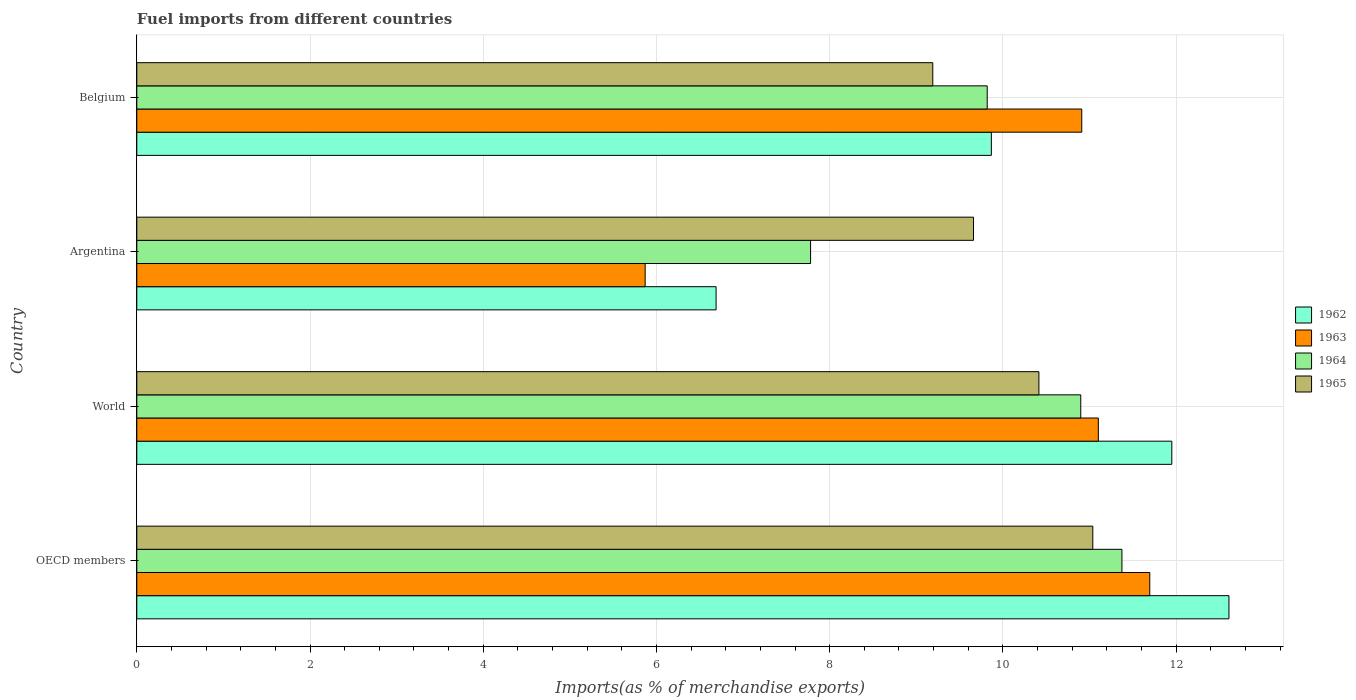How many bars are there on the 1st tick from the top?
Keep it short and to the point. 4. How many bars are there on the 4th tick from the bottom?
Provide a short and direct response. 4. What is the label of the 1st group of bars from the top?
Ensure brevity in your answer.  Belgium. In how many cases, is the number of bars for a given country not equal to the number of legend labels?
Keep it short and to the point. 0. What is the percentage of imports to different countries in 1964 in Argentina?
Offer a terse response. 7.78. Across all countries, what is the maximum percentage of imports to different countries in 1963?
Provide a short and direct response. 11.7. Across all countries, what is the minimum percentage of imports to different countries in 1962?
Offer a very short reply. 6.69. In which country was the percentage of imports to different countries in 1962 minimum?
Your response must be concise. Argentina. What is the total percentage of imports to different countries in 1964 in the graph?
Ensure brevity in your answer.  39.87. What is the difference between the percentage of imports to different countries in 1964 in OECD members and that in World?
Offer a terse response. 0.48. What is the difference between the percentage of imports to different countries in 1965 in Argentina and the percentage of imports to different countries in 1964 in Belgium?
Provide a short and direct response. -0.16. What is the average percentage of imports to different countries in 1963 per country?
Your answer should be very brief. 9.89. What is the difference between the percentage of imports to different countries in 1965 and percentage of imports to different countries in 1964 in OECD members?
Your answer should be compact. -0.34. In how many countries, is the percentage of imports to different countries in 1963 greater than 3.2 %?
Offer a terse response. 4. What is the ratio of the percentage of imports to different countries in 1962 in Argentina to that in World?
Offer a terse response. 0.56. What is the difference between the highest and the second highest percentage of imports to different countries in 1964?
Offer a terse response. 0.48. What is the difference between the highest and the lowest percentage of imports to different countries in 1964?
Your answer should be compact. 3.59. In how many countries, is the percentage of imports to different countries in 1965 greater than the average percentage of imports to different countries in 1965 taken over all countries?
Offer a terse response. 2. Is the sum of the percentage of imports to different countries in 1965 in Argentina and Belgium greater than the maximum percentage of imports to different countries in 1963 across all countries?
Provide a succinct answer. Yes. What does the 4th bar from the top in Belgium represents?
Provide a succinct answer. 1962. What does the 4th bar from the bottom in Belgium represents?
Offer a very short reply. 1965. Is it the case that in every country, the sum of the percentage of imports to different countries in 1964 and percentage of imports to different countries in 1962 is greater than the percentage of imports to different countries in 1965?
Make the answer very short. Yes. How many bars are there?
Your response must be concise. 16. Are all the bars in the graph horizontal?
Offer a very short reply. Yes. Where does the legend appear in the graph?
Your answer should be compact. Center right. How are the legend labels stacked?
Ensure brevity in your answer.  Vertical. What is the title of the graph?
Your response must be concise. Fuel imports from different countries. Does "1994" appear as one of the legend labels in the graph?
Make the answer very short. No. What is the label or title of the X-axis?
Provide a short and direct response. Imports(as % of merchandise exports). What is the label or title of the Y-axis?
Provide a succinct answer. Country. What is the Imports(as % of merchandise exports) in 1962 in OECD members?
Give a very brief answer. 12.61. What is the Imports(as % of merchandise exports) in 1963 in OECD members?
Provide a succinct answer. 11.7. What is the Imports(as % of merchandise exports) of 1964 in OECD members?
Ensure brevity in your answer.  11.37. What is the Imports(as % of merchandise exports) of 1965 in OECD members?
Your answer should be very brief. 11.04. What is the Imports(as % of merchandise exports) of 1962 in World?
Offer a terse response. 11.95. What is the Imports(as % of merchandise exports) of 1963 in World?
Offer a very short reply. 11.1. What is the Imports(as % of merchandise exports) in 1964 in World?
Give a very brief answer. 10.9. What is the Imports(as % of merchandise exports) in 1965 in World?
Your answer should be very brief. 10.42. What is the Imports(as % of merchandise exports) in 1962 in Argentina?
Offer a very short reply. 6.69. What is the Imports(as % of merchandise exports) of 1963 in Argentina?
Your response must be concise. 5.87. What is the Imports(as % of merchandise exports) of 1964 in Argentina?
Give a very brief answer. 7.78. What is the Imports(as % of merchandise exports) in 1965 in Argentina?
Your response must be concise. 9.66. What is the Imports(as % of merchandise exports) in 1962 in Belgium?
Keep it short and to the point. 9.87. What is the Imports(as % of merchandise exports) of 1963 in Belgium?
Your answer should be compact. 10.91. What is the Imports(as % of merchandise exports) of 1964 in Belgium?
Ensure brevity in your answer.  9.82. What is the Imports(as % of merchandise exports) in 1965 in Belgium?
Provide a succinct answer. 9.19. Across all countries, what is the maximum Imports(as % of merchandise exports) of 1962?
Give a very brief answer. 12.61. Across all countries, what is the maximum Imports(as % of merchandise exports) of 1963?
Keep it short and to the point. 11.7. Across all countries, what is the maximum Imports(as % of merchandise exports) of 1964?
Provide a short and direct response. 11.37. Across all countries, what is the maximum Imports(as % of merchandise exports) of 1965?
Your answer should be very brief. 11.04. Across all countries, what is the minimum Imports(as % of merchandise exports) of 1962?
Your answer should be compact. 6.69. Across all countries, what is the minimum Imports(as % of merchandise exports) of 1963?
Make the answer very short. 5.87. Across all countries, what is the minimum Imports(as % of merchandise exports) of 1964?
Your response must be concise. 7.78. Across all countries, what is the minimum Imports(as % of merchandise exports) of 1965?
Your response must be concise. 9.19. What is the total Imports(as % of merchandise exports) in 1962 in the graph?
Your answer should be very brief. 41.12. What is the total Imports(as % of merchandise exports) of 1963 in the graph?
Keep it short and to the point. 39.58. What is the total Imports(as % of merchandise exports) in 1964 in the graph?
Keep it short and to the point. 39.87. What is the total Imports(as % of merchandise exports) in 1965 in the graph?
Ensure brevity in your answer.  40.31. What is the difference between the Imports(as % of merchandise exports) in 1962 in OECD members and that in World?
Give a very brief answer. 0.66. What is the difference between the Imports(as % of merchandise exports) in 1963 in OECD members and that in World?
Your answer should be very brief. 0.59. What is the difference between the Imports(as % of merchandise exports) in 1964 in OECD members and that in World?
Make the answer very short. 0.48. What is the difference between the Imports(as % of merchandise exports) of 1965 in OECD members and that in World?
Keep it short and to the point. 0.62. What is the difference between the Imports(as % of merchandise exports) of 1962 in OECD members and that in Argentina?
Keep it short and to the point. 5.92. What is the difference between the Imports(as % of merchandise exports) of 1963 in OECD members and that in Argentina?
Keep it short and to the point. 5.83. What is the difference between the Imports(as % of merchandise exports) in 1964 in OECD members and that in Argentina?
Provide a succinct answer. 3.59. What is the difference between the Imports(as % of merchandise exports) of 1965 in OECD members and that in Argentina?
Your response must be concise. 1.38. What is the difference between the Imports(as % of merchandise exports) of 1962 in OECD members and that in Belgium?
Your answer should be very brief. 2.74. What is the difference between the Imports(as % of merchandise exports) in 1963 in OECD members and that in Belgium?
Make the answer very short. 0.79. What is the difference between the Imports(as % of merchandise exports) in 1964 in OECD members and that in Belgium?
Ensure brevity in your answer.  1.56. What is the difference between the Imports(as % of merchandise exports) of 1965 in OECD members and that in Belgium?
Provide a succinct answer. 1.85. What is the difference between the Imports(as % of merchandise exports) of 1962 in World and that in Argentina?
Keep it short and to the point. 5.26. What is the difference between the Imports(as % of merchandise exports) in 1963 in World and that in Argentina?
Offer a terse response. 5.23. What is the difference between the Imports(as % of merchandise exports) of 1964 in World and that in Argentina?
Give a very brief answer. 3.12. What is the difference between the Imports(as % of merchandise exports) of 1965 in World and that in Argentina?
Provide a succinct answer. 0.76. What is the difference between the Imports(as % of merchandise exports) of 1962 in World and that in Belgium?
Provide a succinct answer. 2.08. What is the difference between the Imports(as % of merchandise exports) in 1963 in World and that in Belgium?
Ensure brevity in your answer.  0.19. What is the difference between the Imports(as % of merchandise exports) in 1964 in World and that in Belgium?
Your answer should be very brief. 1.08. What is the difference between the Imports(as % of merchandise exports) of 1965 in World and that in Belgium?
Give a very brief answer. 1.23. What is the difference between the Imports(as % of merchandise exports) of 1962 in Argentina and that in Belgium?
Make the answer very short. -3.18. What is the difference between the Imports(as % of merchandise exports) of 1963 in Argentina and that in Belgium?
Give a very brief answer. -5.04. What is the difference between the Imports(as % of merchandise exports) of 1964 in Argentina and that in Belgium?
Offer a terse response. -2.04. What is the difference between the Imports(as % of merchandise exports) of 1965 in Argentina and that in Belgium?
Keep it short and to the point. 0.47. What is the difference between the Imports(as % of merchandise exports) of 1962 in OECD members and the Imports(as % of merchandise exports) of 1963 in World?
Offer a very short reply. 1.51. What is the difference between the Imports(as % of merchandise exports) of 1962 in OECD members and the Imports(as % of merchandise exports) of 1964 in World?
Ensure brevity in your answer.  1.71. What is the difference between the Imports(as % of merchandise exports) of 1962 in OECD members and the Imports(as % of merchandise exports) of 1965 in World?
Keep it short and to the point. 2.19. What is the difference between the Imports(as % of merchandise exports) of 1963 in OECD members and the Imports(as % of merchandise exports) of 1964 in World?
Give a very brief answer. 0.8. What is the difference between the Imports(as % of merchandise exports) of 1963 in OECD members and the Imports(as % of merchandise exports) of 1965 in World?
Offer a very short reply. 1.28. What is the difference between the Imports(as % of merchandise exports) of 1964 in OECD members and the Imports(as % of merchandise exports) of 1965 in World?
Provide a succinct answer. 0.96. What is the difference between the Imports(as % of merchandise exports) of 1962 in OECD members and the Imports(as % of merchandise exports) of 1963 in Argentina?
Keep it short and to the point. 6.74. What is the difference between the Imports(as % of merchandise exports) in 1962 in OECD members and the Imports(as % of merchandise exports) in 1964 in Argentina?
Offer a very short reply. 4.83. What is the difference between the Imports(as % of merchandise exports) of 1962 in OECD members and the Imports(as % of merchandise exports) of 1965 in Argentina?
Provide a succinct answer. 2.95. What is the difference between the Imports(as % of merchandise exports) in 1963 in OECD members and the Imports(as % of merchandise exports) in 1964 in Argentina?
Your answer should be very brief. 3.92. What is the difference between the Imports(as % of merchandise exports) of 1963 in OECD members and the Imports(as % of merchandise exports) of 1965 in Argentina?
Keep it short and to the point. 2.04. What is the difference between the Imports(as % of merchandise exports) of 1964 in OECD members and the Imports(as % of merchandise exports) of 1965 in Argentina?
Offer a very short reply. 1.71. What is the difference between the Imports(as % of merchandise exports) of 1962 in OECD members and the Imports(as % of merchandise exports) of 1963 in Belgium?
Offer a very short reply. 1.7. What is the difference between the Imports(as % of merchandise exports) of 1962 in OECD members and the Imports(as % of merchandise exports) of 1964 in Belgium?
Offer a very short reply. 2.79. What is the difference between the Imports(as % of merchandise exports) of 1962 in OECD members and the Imports(as % of merchandise exports) of 1965 in Belgium?
Offer a terse response. 3.42. What is the difference between the Imports(as % of merchandise exports) in 1963 in OECD members and the Imports(as % of merchandise exports) in 1964 in Belgium?
Provide a succinct answer. 1.88. What is the difference between the Imports(as % of merchandise exports) of 1963 in OECD members and the Imports(as % of merchandise exports) of 1965 in Belgium?
Give a very brief answer. 2.51. What is the difference between the Imports(as % of merchandise exports) in 1964 in OECD members and the Imports(as % of merchandise exports) in 1965 in Belgium?
Provide a short and direct response. 2.18. What is the difference between the Imports(as % of merchandise exports) of 1962 in World and the Imports(as % of merchandise exports) of 1963 in Argentina?
Give a very brief answer. 6.08. What is the difference between the Imports(as % of merchandise exports) in 1962 in World and the Imports(as % of merchandise exports) in 1964 in Argentina?
Keep it short and to the point. 4.17. What is the difference between the Imports(as % of merchandise exports) in 1962 in World and the Imports(as % of merchandise exports) in 1965 in Argentina?
Your response must be concise. 2.29. What is the difference between the Imports(as % of merchandise exports) in 1963 in World and the Imports(as % of merchandise exports) in 1964 in Argentina?
Provide a short and direct response. 3.32. What is the difference between the Imports(as % of merchandise exports) of 1963 in World and the Imports(as % of merchandise exports) of 1965 in Argentina?
Offer a terse response. 1.44. What is the difference between the Imports(as % of merchandise exports) of 1964 in World and the Imports(as % of merchandise exports) of 1965 in Argentina?
Your response must be concise. 1.24. What is the difference between the Imports(as % of merchandise exports) of 1962 in World and the Imports(as % of merchandise exports) of 1963 in Belgium?
Make the answer very short. 1.04. What is the difference between the Imports(as % of merchandise exports) in 1962 in World and the Imports(as % of merchandise exports) in 1964 in Belgium?
Your response must be concise. 2.13. What is the difference between the Imports(as % of merchandise exports) of 1962 in World and the Imports(as % of merchandise exports) of 1965 in Belgium?
Offer a terse response. 2.76. What is the difference between the Imports(as % of merchandise exports) of 1963 in World and the Imports(as % of merchandise exports) of 1964 in Belgium?
Provide a short and direct response. 1.28. What is the difference between the Imports(as % of merchandise exports) of 1963 in World and the Imports(as % of merchandise exports) of 1965 in Belgium?
Ensure brevity in your answer.  1.91. What is the difference between the Imports(as % of merchandise exports) in 1964 in World and the Imports(as % of merchandise exports) in 1965 in Belgium?
Give a very brief answer. 1.71. What is the difference between the Imports(as % of merchandise exports) in 1962 in Argentina and the Imports(as % of merchandise exports) in 1963 in Belgium?
Provide a succinct answer. -4.22. What is the difference between the Imports(as % of merchandise exports) of 1962 in Argentina and the Imports(as % of merchandise exports) of 1964 in Belgium?
Offer a terse response. -3.13. What is the difference between the Imports(as % of merchandise exports) in 1962 in Argentina and the Imports(as % of merchandise exports) in 1965 in Belgium?
Your answer should be very brief. -2.5. What is the difference between the Imports(as % of merchandise exports) in 1963 in Argentina and the Imports(as % of merchandise exports) in 1964 in Belgium?
Give a very brief answer. -3.95. What is the difference between the Imports(as % of merchandise exports) of 1963 in Argentina and the Imports(as % of merchandise exports) of 1965 in Belgium?
Offer a very short reply. -3.32. What is the difference between the Imports(as % of merchandise exports) in 1964 in Argentina and the Imports(as % of merchandise exports) in 1965 in Belgium?
Provide a short and direct response. -1.41. What is the average Imports(as % of merchandise exports) in 1962 per country?
Keep it short and to the point. 10.28. What is the average Imports(as % of merchandise exports) of 1963 per country?
Give a very brief answer. 9.89. What is the average Imports(as % of merchandise exports) in 1964 per country?
Give a very brief answer. 9.97. What is the average Imports(as % of merchandise exports) in 1965 per country?
Offer a very short reply. 10.08. What is the difference between the Imports(as % of merchandise exports) of 1962 and Imports(as % of merchandise exports) of 1963 in OECD members?
Provide a short and direct response. 0.91. What is the difference between the Imports(as % of merchandise exports) of 1962 and Imports(as % of merchandise exports) of 1964 in OECD members?
Keep it short and to the point. 1.24. What is the difference between the Imports(as % of merchandise exports) of 1962 and Imports(as % of merchandise exports) of 1965 in OECD members?
Provide a succinct answer. 1.57. What is the difference between the Imports(as % of merchandise exports) in 1963 and Imports(as % of merchandise exports) in 1964 in OECD members?
Offer a terse response. 0.32. What is the difference between the Imports(as % of merchandise exports) in 1963 and Imports(as % of merchandise exports) in 1965 in OECD members?
Keep it short and to the point. 0.66. What is the difference between the Imports(as % of merchandise exports) in 1964 and Imports(as % of merchandise exports) in 1965 in OECD members?
Ensure brevity in your answer.  0.34. What is the difference between the Imports(as % of merchandise exports) in 1962 and Imports(as % of merchandise exports) in 1963 in World?
Keep it short and to the point. 0.85. What is the difference between the Imports(as % of merchandise exports) in 1962 and Imports(as % of merchandise exports) in 1964 in World?
Your answer should be very brief. 1.05. What is the difference between the Imports(as % of merchandise exports) in 1962 and Imports(as % of merchandise exports) in 1965 in World?
Offer a very short reply. 1.53. What is the difference between the Imports(as % of merchandise exports) of 1963 and Imports(as % of merchandise exports) of 1964 in World?
Make the answer very short. 0.2. What is the difference between the Imports(as % of merchandise exports) of 1963 and Imports(as % of merchandise exports) of 1965 in World?
Offer a very short reply. 0.69. What is the difference between the Imports(as % of merchandise exports) in 1964 and Imports(as % of merchandise exports) in 1965 in World?
Keep it short and to the point. 0.48. What is the difference between the Imports(as % of merchandise exports) in 1962 and Imports(as % of merchandise exports) in 1963 in Argentina?
Your answer should be compact. 0.82. What is the difference between the Imports(as % of merchandise exports) of 1962 and Imports(as % of merchandise exports) of 1964 in Argentina?
Give a very brief answer. -1.09. What is the difference between the Imports(as % of merchandise exports) in 1962 and Imports(as % of merchandise exports) in 1965 in Argentina?
Offer a very short reply. -2.97. What is the difference between the Imports(as % of merchandise exports) in 1963 and Imports(as % of merchandise exports) in 1964 in Argentina?
Keep it short and to the point. -1.91. What is the difference between the Imports(as % of merchandise exports) of 1963 and Imports(as % of merchandise exports) of 1965 in Argentina?
Make the answer very short. -3.79. What is the difference between the Imports(as % of merchandise exports) of 1964 and Imports(as % of merchandise exports) of 1965 in Argentina?
Provide a succinct answer. -1.88. What is the difference between the Imports(as % of merchandise exports) of 1962 and Imports(as % of merchandise exports) of 1963 in Belgium?
Keep it short and to the point. -1.04. What is the difference between the Imports(as % of merchandise exports) in 1962 and Imports(as % of merchandise exports) in 1964 in Belgium?
Make the answer very short. 0.05. What is the difference between the Imports(as % of merchandise exports) in 1962 and Imports(as % of merchandise exports) in 1965 in Belgium?
Keep it short and to the point. 0.68. What is the difference between the Imports(as % of merchandise exports) in 1963 and Imports(as % of merchandise exports) in 1964 in Belgium?
Your answer should be compact. 1.09. What is the difference between the Imports(as % of merchandise exports) in 1963 and Imports(as % of merchandise exports) in 1965 in Belgium?
Offer a very short reply. 1.72. What is the difference between the Imports(as % of merchandise exports) of 1964 and Imports(as % of merchandise exports) of 1965 in Belgium?
Offer a very short reply. 0.63. What is the ratio of the Imports(as % of merchandise exports) of 1962 in OECD members to that in World?
Provide a short and direct response. 1.06. What is the ratio of the Imports(as % of merchandise exports) in 1963 in OECD members to that in World?
Keep it short and to the point. 1.05. What is the ratio of the Imports(as % of merchandise exports) of 1964 in OECD members to that in World?
Your answer should be compact. 1.04. What is the ratio of the Imports(as % of merchandise exports) in 1965 in OECD members to that in World?
Your answer should be very brief. 1.06. What is the ratio of the Imports(as % of merchandise exports) in 1962 in OECD members to that in Argentina?
Your response must be concise. 1.89. What is the ratio of the Imports(as % of merchandise exports) of 1963 in OECD members to that in Argentina?
Offer a terse response. 1.99. What is the ratio of the Imports(as % of merchandise exports) in 1964 in OECD members to that in Argentina?
Keep it short and to the point. 1.46. What is the ratio of the Imports(as % of merchandise exports) in 1965 in OECD members to that in Argentina?
Your response must be concise. 1.14. What is the ratio of the Imports(as % of merchandise exports) of 1962 in OECD members to that in Belgium?
Provide a succinct answer. 1.28. What is the ratio of the Imports(as % of merchandise exports) of 1963 in OECD members to that in Belgium?
Your response must be concise. 1.07. What is the ratio of the Imports(as % of merchandise exports) in 1964 in OECD members to that in Belgium?
Provide a short and direct response. 1.16. What is the ratio of the Imports(as % of merchandise exports) of 1965 in OECD members to that in Belgium?
Your answer should be compact. 1.2. What is the ratio of the Imports(as % of merchandise exports) in 1962 in World to that in Argentina?
Offer a very short reply. 1.79. What is the ratio of the Imports(as % of merchandise exports) in 1963 in World to that in Argentina?
Offer a terse response. 1.89. What is the ratio of the Imports(as % of merchandise exports) in 1964 in World to that in Argentina?
Provide a succinct answer. 1.4. What is the ratio of the Imports(as % of merchandise exports) of 1965 in World to that in Argentina?
Offer a very short reply. 1.08. What is the ratio of the Imports(as % of merchandise exports) in 1962 in World to that in Belgium?
Your answer should be compact. 1.21. What is the ratio of the Imports(as % of merchandise exports) of 1963 in World to that in Belgium?
Your response must be concise. 1.02. What is the ratio of the Imports(as % of merchandise exports) of 1964 in World to that in Belgium?
Give a very brief answer. 1.11. What is the ratio of the Imports(as % of merchandise exports) of 1965 in World to that in Belgium?
Give a very brief answer. 1.13. What is the ratio of the Imports(as % of merchandise exports) in 1962 in Argentina to that in Belgium?
Give a very brief answer. 0.68. What is the ratio of the Imports(as % of merchandise exports) of 1963 in Argentina to that in Belgium?
Your response must be concise. 0.54. What is the ratio of the Imports(as % of merchandise exports) in 1964 in Argentina to that in Belgium?
Your response must be concise. 0.79. What is the ratio of the Imports(as % of merchandise exports) in 1965 in Argentina to that in Belgium?
Your response must be concise. 1.05. What is the difference between the highest and the second highest Imports(as % of merchandise exports) of 1962?
Keep it short and to the point. 0.66. What is the difference between the highest and the second highest Imports(as % of merchandise exports) in 1963?
Your answer should be very brief. 0.59. What is the difference between the highest and the second highest Imports(as % of merchandise exports) of 1964?
Keep it short and to the point. 0.48. What is the difference between the highest and the second highest Imports(as % of merchandise exports) of 1965?
Give a very brief answer. 0.62. What is the difference between the highest and the lowest Imports(as % of merchandise exports) of 1962?
Your answer should be compact. 5.92. What is the difference between the highest and the lowest Imports(as % of merchandise exports) of 1963?
Give a very brief answer. 5.83. What is the difference between the highest and the lowest Imports(as % of merchandise exports) in 1964?
Provide a short and direct response. 3.59. What is the difference between the highest and the lowest Imports(as % of merchandise exports) of 1965?
Give a very brief answer. 1.85. 